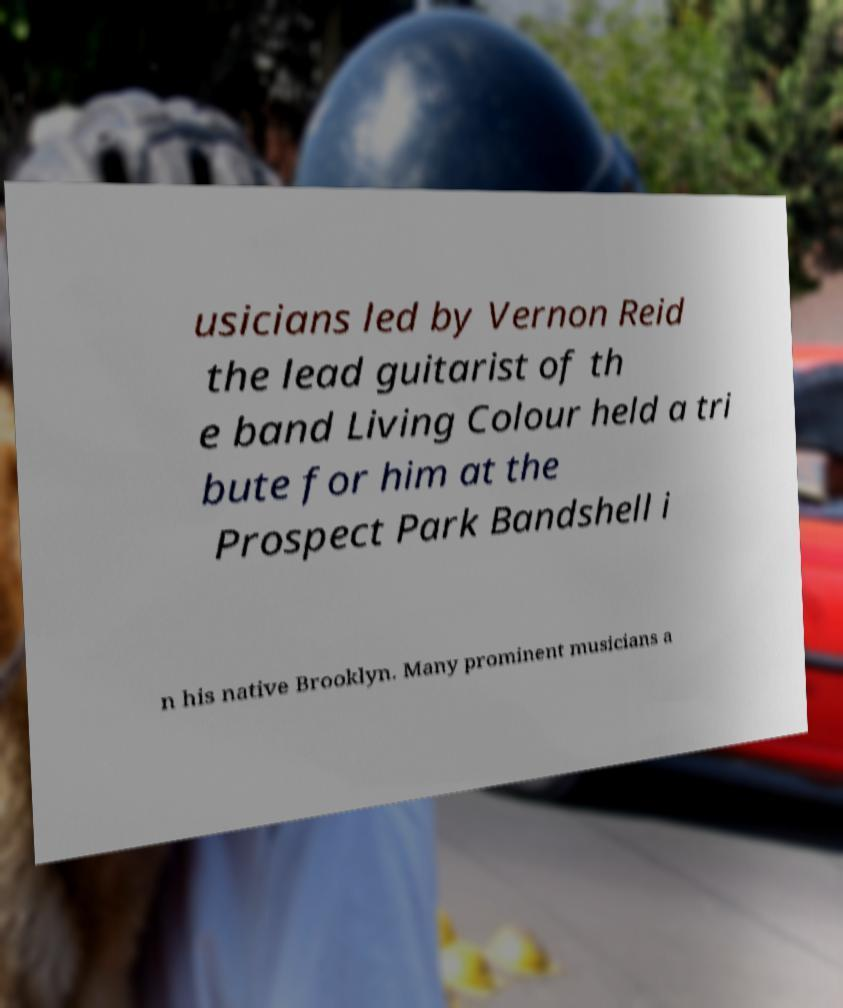What messages or text are displayed in this image? I need them in a readable, typed format. usicians led by Vernon Reid the lead guitarist of th e band Living Colour held a tri bute for him at the Prospect Park Bandshell i n his native Brooklyn. Many prominent musicians a 